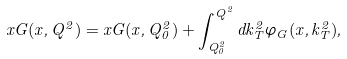<formula> <loc_0><loc_0><loc_500><loc_500>x G ( x , Q ^ { 2 } ) = x G ( x , Q _ { 0 } ^ { 2 } ) + \int _ { Q _ { 0 } ^ { 2 } } ^ { Q ^ { 2 } } d k _ { T } ^ { 2 } \varphi _ { G } ( x , k _ { T } ^ { 2 } ) ,</formula> 